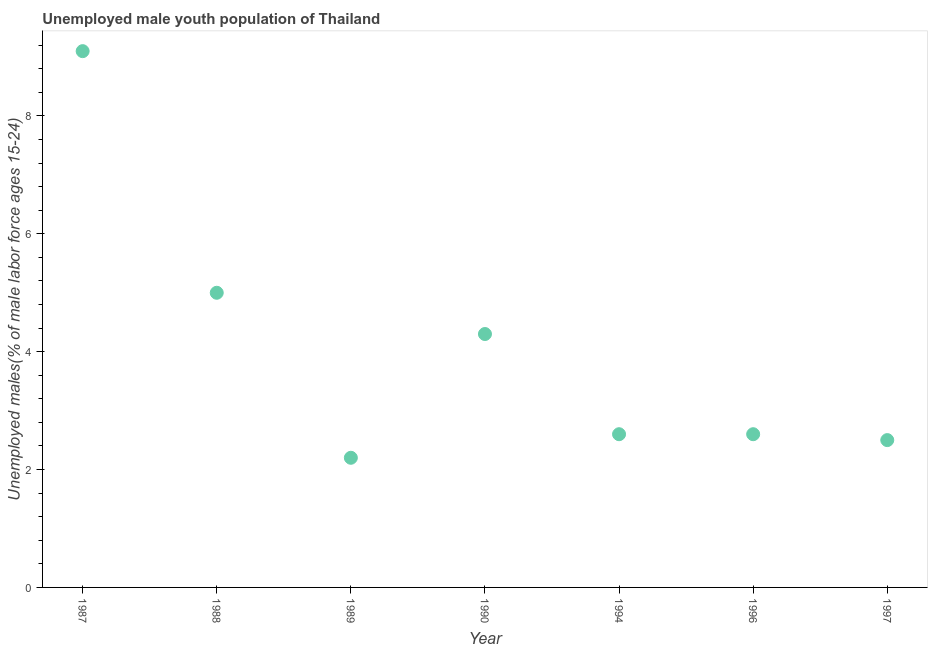What is the unemployed male youth in 1990?
Give a very brief answer. 4.3. Across all years, what is the maximum unemployed male youth?
Provide a short and direct response. 9.1. Across all years, what is the minimum unemployed male youth?
Provide a short and direct response. 2.2. In which year was the unemployed male youth maximum?
Your response must be concise. 1987. What is the sum of the unemployed male youth?
Keep it short and to the point. 28.3. What is the difference between the unemployed male youth in 1987 and 1996?
Offer a very short reply. 6.5. What is the average unemployed male youth per year?
Offer a terse response. 4.04. What is the median unemployed male youth?
Your answer should be very brief. 2.6. In how many years, is the unemployed male youth greater than 6.8 %?
Keep it short and to the point. 1. What is the ratio of the unemployed male youth in 1990 to that in 1997?
Keep it short and to the point. 1.72. Is the unemployed male youth in 1987 less than that in 1988?
Offer a very short reply. No. Is the difference between the unemployed male youth in 1987 and 1996 greater than the difference between any two years?
Provide a short and direct response. No. What is the difference between the highest and the second highest unemployed male youth?
Keep it short and to the point. 4.1. Is the sum of the unemployed male youth in 1990 and 1997 greater than the maximum unemployed male youth across all years?
Make the answer very short. No. What is the difference between the highest and the lowest unemployed male youth?
Keep it short and to the point. 6.9. How many dotlines are there?
Ensure brevity in your answer.  1. How many years are there in the graph?
Your answer should be very brief. 7. What is the title of the graph?
Ensure brevity in your answer.  Unemployed male youth population of Thailand. What is the label or title of the Y-axis?
Provide a succinct answer. Unemployed males(% of male labor force ages 15-24). What is the Unemployed males(% of male labor force ages 15-24) in 1987?
Provide a succinct answer. 9.1. What is the Unemployed males(% of male labor force ages 15-24) in 1988?
Offer a very short reply. 5. What is the Unemployed males(% of male labor force ages 15-24) in 1989?
Your answer should be very brief. 2.2. What is the Unemployed males(% of male labor force ages 15-24) in 1990?
Offer a terse response. 4.3. What is the Unemployed males(% of male labor force ages 15-24) in 1994?
Provide a succinct answer. 2.6. What is the Unemployed males(% of male labor force ages 15-24) in 1996?
Your answer should be compact. 2.6. What is the Unemployed males(% of male labor force ages 15-24) in 1997?
Provide a succinct answer. 2.5. What is the difference between the Unemployed males(% of male labor force ages 15-24) in 1987 and 1994?
Provide a succinct answer. 6.5. What is the difference between the Unemployed males(% of male labor force ages 15-24) in 1988 and 1994?
Ensure brevity in your answer.  2.4. What is the difference between the Unemployed males(% of male labor force ages 15-24) in 1989 and 1990?
Provide a short and direct response. -2.1. What is the difference between the Unemployed males(% of male labor force ages 15-24) in 1989 and 1994?
Your answer should be compact. -0.4. What is the difference between the Unemployed males(% of male labor force ages 15-24) in 1989 and 1996?
Your response must be concise. -0.4. What is the difference between the Unemployed males(% of male labor force ages 15-24) in 1990 and 1994?
Provide a short and direct response. 1.7. What is the difference between the Unemployed males(% of male labor force ages 15-24) in 1990 and 1997?
Your answer should be compact. 1.8. What is the difference between the Unemployed males(% of male labor force ages 15-24) in 1994 and 1996?
Make the answer very short. 0. What is the ratio of the Unemployed males(% of male labor force ages 15-24) in 1987 to that in 1988?
Give a very brief answer. 1.82. What is the ratio of the Unemployed males(% of male labor force ages 15-24) in 1987 to that in 1989?
Offer a terse response. 4.14. What is the ratio of the Unemployed males(% of male labor force ages 15-24) in 1987 to that in 1990?
Your answer should be very brief. 2.12. What is the ratio of the Unemployed males(% of male labor force ages 15-24) in 1987 to that in 1994?
Ensure brevity in your answer.  3.5. What is the ratio of the Unemployed males(% of male labor force ages 15-24) in 1987 to that in 1997?
Your response must be concise. 3.64. What is the ratio of the Unemployed males(% of male labor force ages 15-24) in 1988 to that in 1989?
Your answer should be very brief. 2.27. What is the ratio of the Unemployed males(% of male labor force ages 15-24) in 1988 to that in 1990?
Offer a terse response. 1.16. What is the ratio of the Unemployed males(% of male labor force ages 15-24) in 1988 to that in 1994?
Your response must be concise. 1.92. What is the ratio of the Unemployed males(% of male labor force ages 15-24) in 1988 to that in 1996?
Offer a very short reply. 1.92. What is the ratio of the Unemployed males(% of male labor force ages 15-24) in 1988 to that in 1997?
Provide a succinct answer. 2. What is the ratio of the Unemployed males(% of male labor force ages 15-24) in 1989 to that in 1990?
Make the answer very short. 0.51. What is the ratio of the Unemployed males(% of male labor force ages 15-24) in 1989 to that in 1994?
Your answer should be very brief. 0.85. What is the ratio of the Unemployed males(% of male labor force ages 15-24) in 1989 to that in 1996?
Your answer should be compact. 0.85. What is the ratio of the Unemployed males(% of male labor force ages 15-24) in 1989 to that in 1997?
Make the answer very short. 0.88. What is the ratio of the Unemployed males(% of male labor force ages 15-24) in 1990 to that in 1994?
Offer a very short reply. 1.65. What is the ratio of the Unemployed males(% of male labor force ages 15-24) in 1990 to that in 1996?
Your answer should be very brief. 1.65. What is the ratio of the Unemployed males(% of male labor force ages 15-24) in 1990 to that in 1997?
Your answer should be very brief. 1.72. What is the ratio of the Unemployed males(% of male labor force ages 15-24) in 1994 to that in 1996?
Offer a very short reply. 1. 